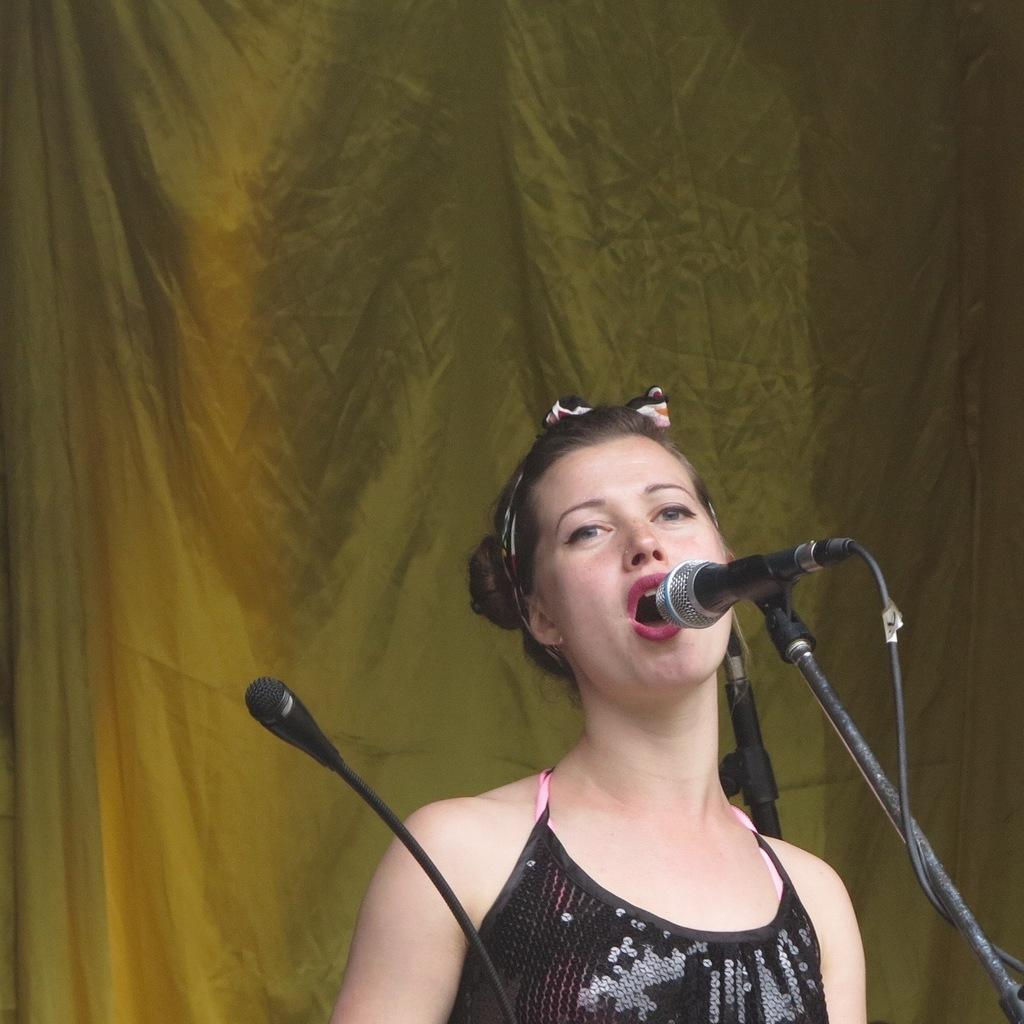Who is the main subject in the image? There is a woman in the image. What is the woman doing in the image? The woman is singing. What object is the woman using while singing? The woman is in front of a microphone. What can be seen behind the woman? There is a curtain behind the woman. What type of rifle is the woman holding while singing in the image? There is no rifle present in the image; the woman is only holding a microphone while singing. 